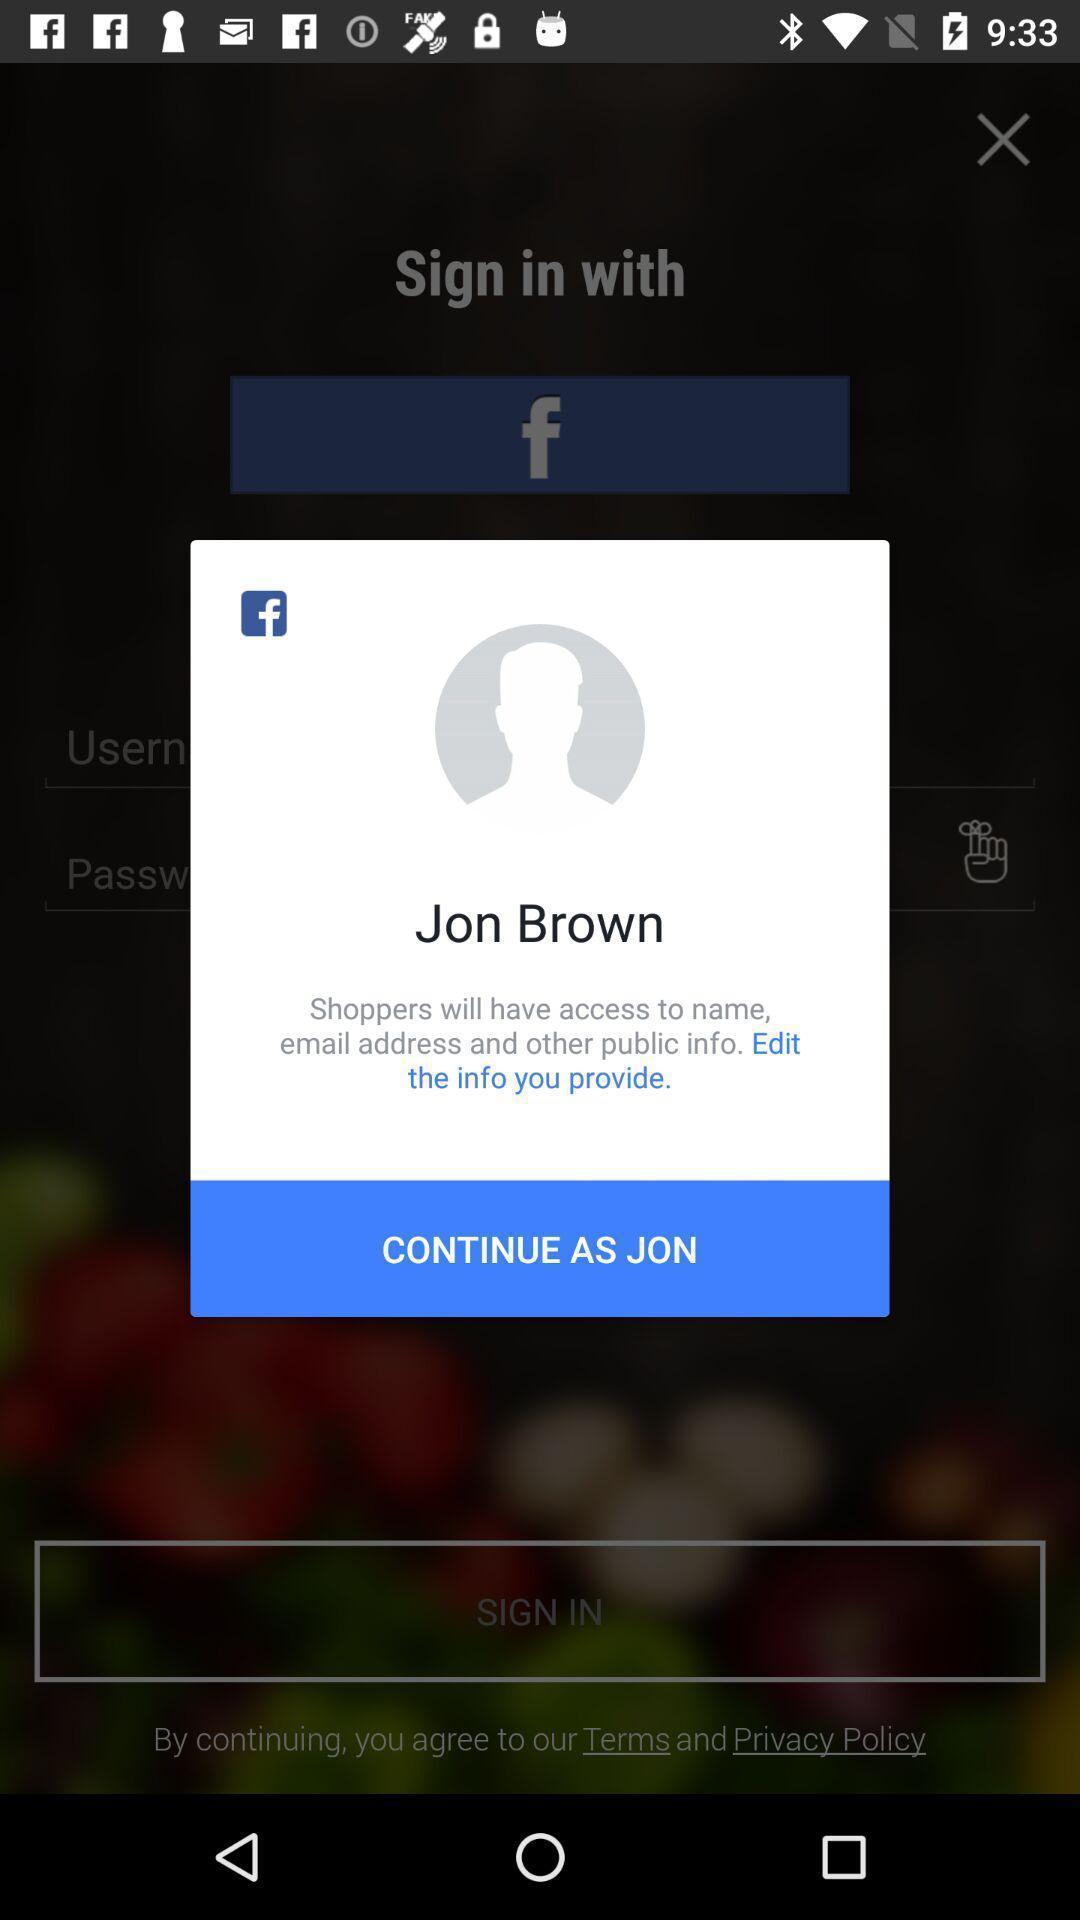What can you discern from this picture? Pop-up shows to continue with social app. 